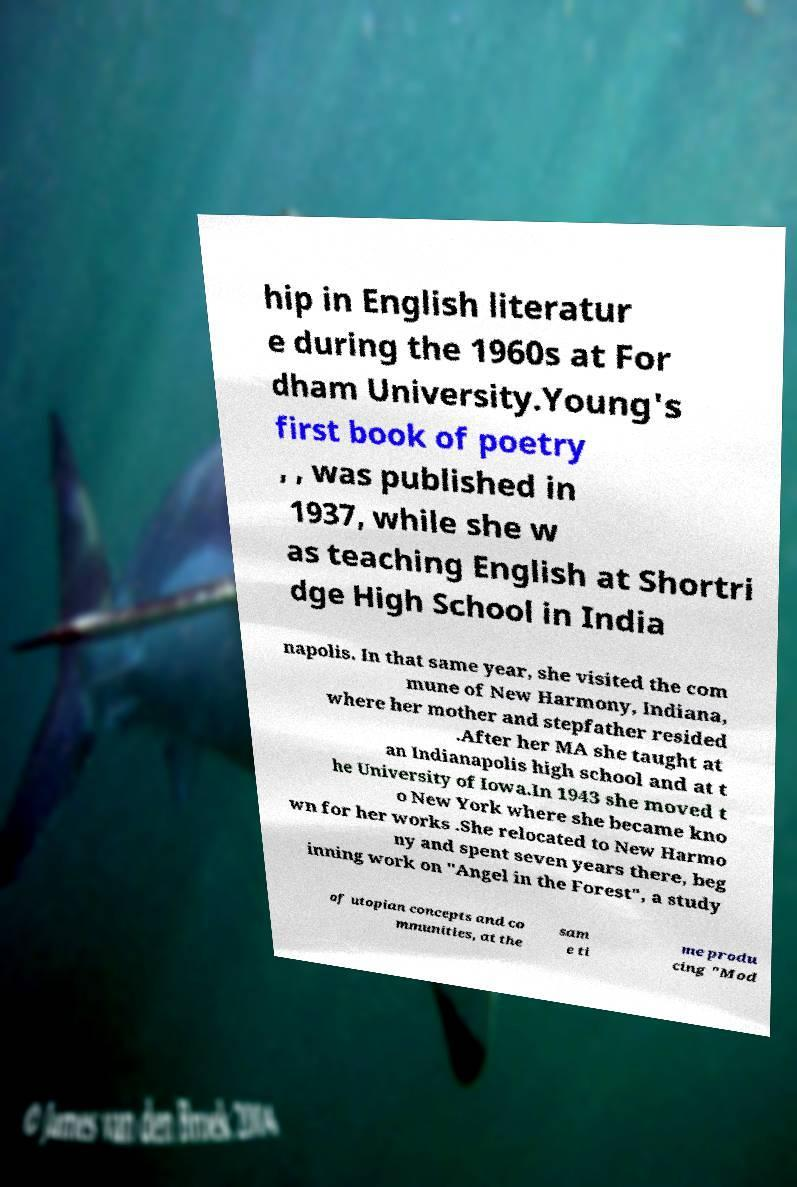Please read and relay the text visible in this image. What does it say? hip in English literatur e during the 1960s at For dham University.Young's first book of poetry , , was published in 1937, while she w as teaching English at Shortri dge High School in India napolis. In that same year, she visited the com mune of New Harmony, Indiana, where her mother and stepfather resided .After her MA she taught at an Indianapolis high school and at t he University of Iowa.In 1943 she moved t o New York where she became kno wn for her works .She relocated to New Harmo ny and spent seven years there, beg inning work on "Angel in the Forest", a study of utopian concepts and co mmunities, at the sam e ti me produ cing "Mod 